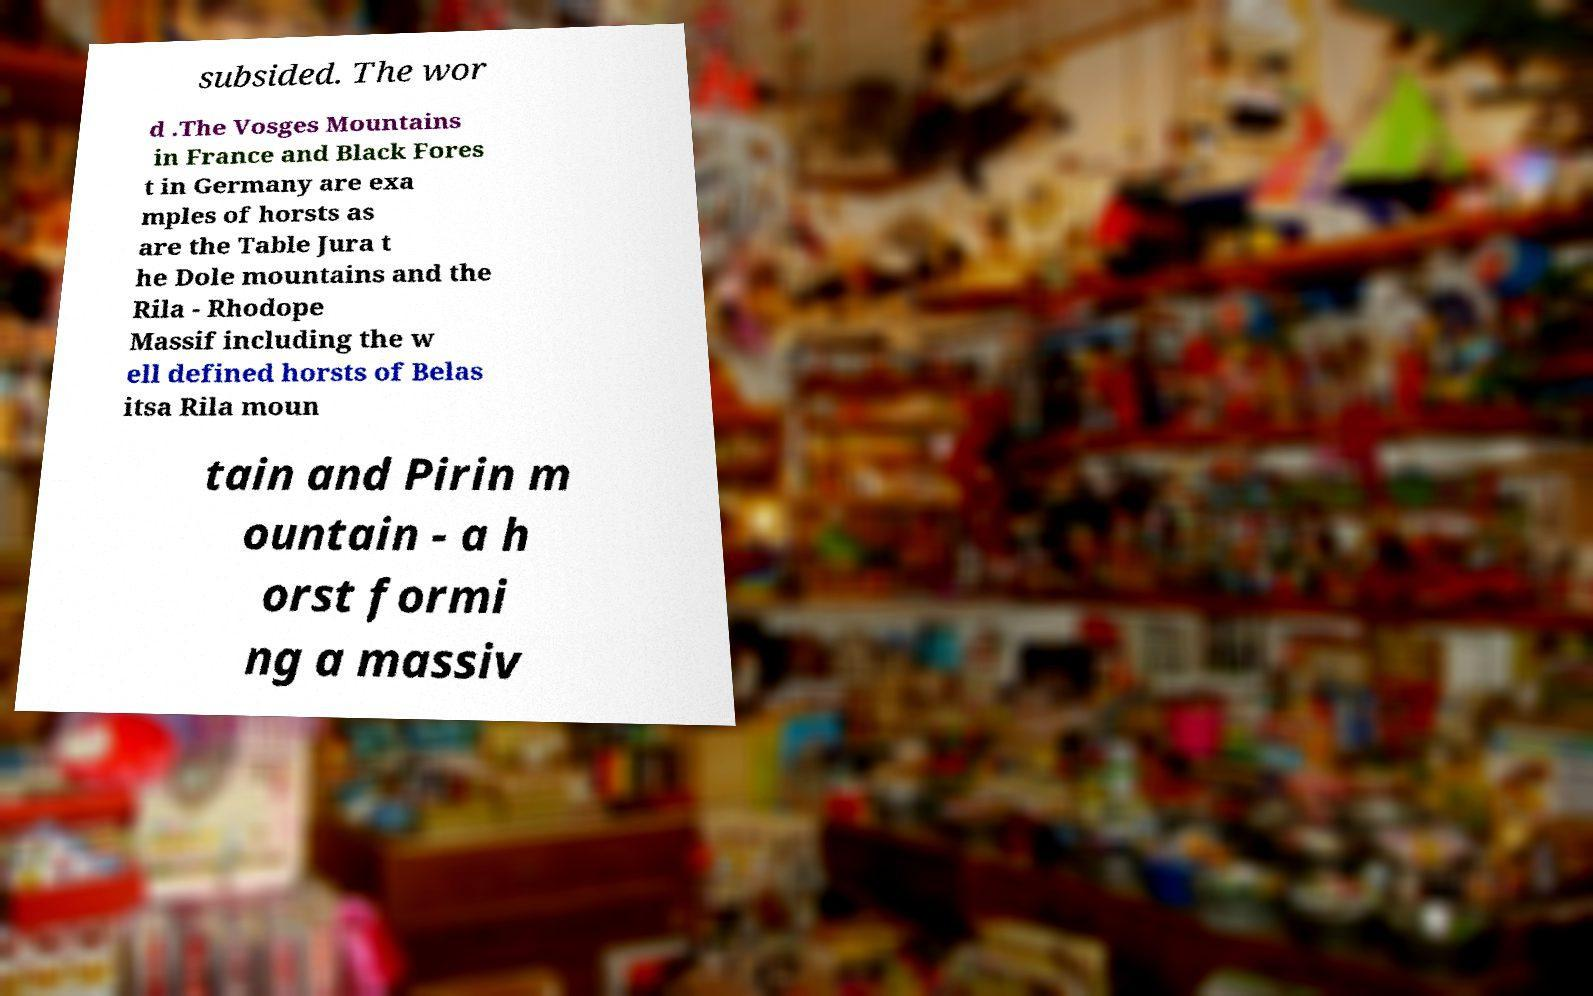Can you accurately transcribe the text from the provided image for me? subsided. The wor d .The Vosges Mountains in France and Black Fores t in Germany are exa mples of horsts as are the Table Jura t he Dole mountains and the Rila - Rhodope Massif including the w ell defined horsts of Belas itsa Rila moun tain and Pirin m ountain - a h orst formi ng a massiv 